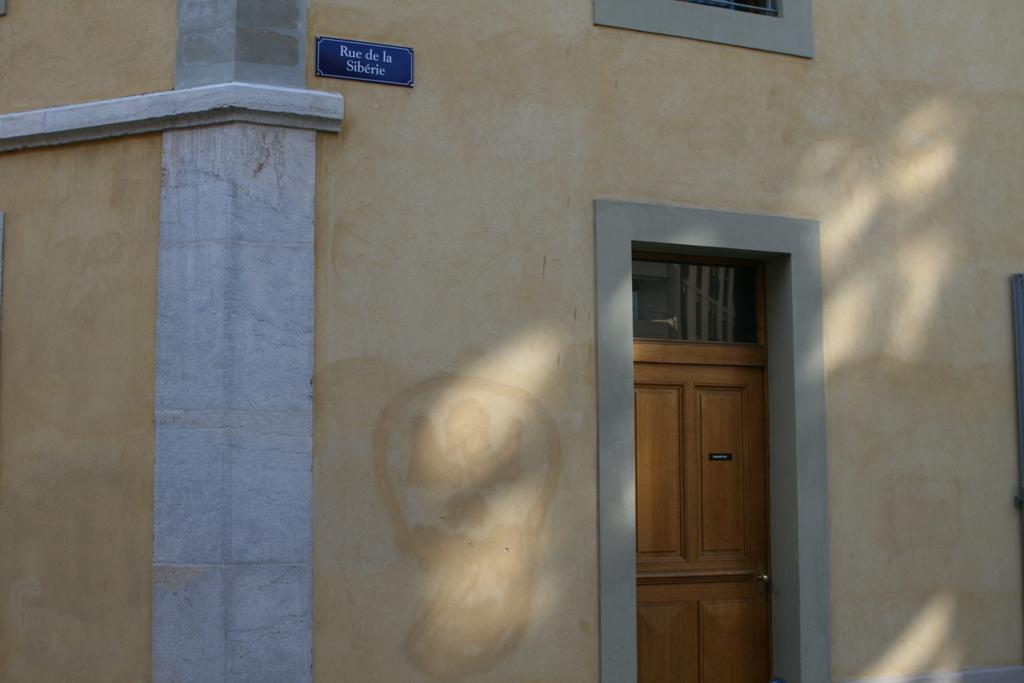What is the main subject of the image? The main subject of the image is a building. Can you describe the building in the image? The building has a door. What else can be seen on the building in the image? There is a board on the wall at the top of the image. What type of meat is hanging from the board on the wall in the image? There is no meat present in the image; the board on the wall has no visible items hanging from it. 